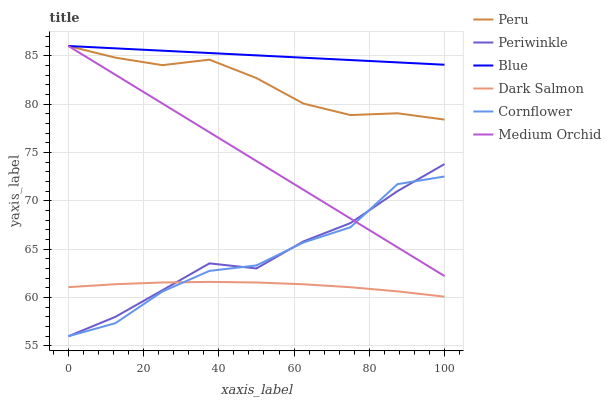Does Dark Salmon have the minimum area under the curve?
Answer yes or no. Yes. Does Blue have the maximum area under the curve?
Answer yes or no. Yes. Does Cornflower have the minimum area under the curve?
Answer yes or no. No. Does Cornflower have the maximum area under the curve?
Answer yes or no. No. Is Medium Orchid the smoothest?
Answer yes or no. Yes. Is Cornflower the roughest?
Answer yes or no. Yes. Is Cornflower the smoothest?
Answer yes or no. No. Is Medium Orchid the roughest?
Answer yes or no. No. Does Cornflower have the lowest value?
Answer yes or no. Yes. Does Medium Orchid have the lowest value?
Answer yes or no. No. Does Peru have the highest value?
Answer yes or no. Yes. Does Cornflower have the highest value?
Answer yes or no. No. Is Periwinkle less than Blue?
Answer yes or no. Yes. Is Blue greater than Periwinkle?
Answer yes or no. Yes. Does Medium Orchid intersect Blue?
Answer yes or no. Yes. Is Medium Orchid less than Blue?
Answer yes or no. No. Is Medium Orchid greater than Blue?
Answer yes or no. No. Does Periwinkle intersect Blue?
Answer yes or no. No. 